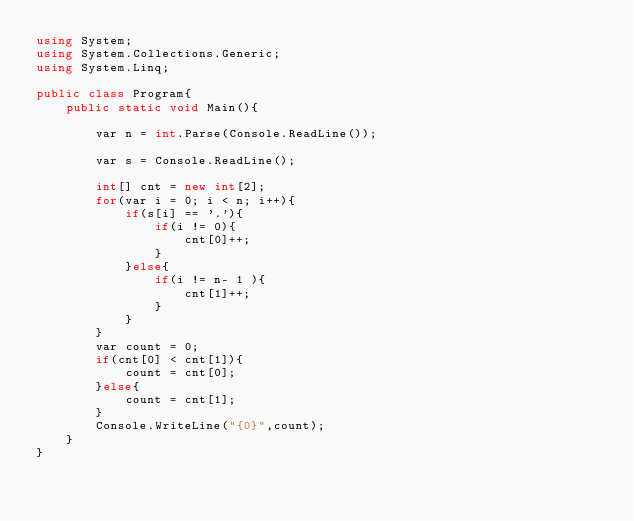<code> <loc_0><loc_0><loc_500><loc_500><_C#_>using System;
using System.Collections.Generic;
using System.Linq;

public class Program{
    public static void Main(){
        
        var n = int.Parse(Console.ReadLine());
        
        var s = Console.ReadLine();
        
        int[] cnt = new int[2];
        for(var i = 0; i < n; i++){
            if(s[i] == '.'){
                if(i != 0){
                    cnt[0]++;
                }
            }else{
                if(i != n- 1 ){
                    cnt[1]++;
                }
            }
        }
        var count = 0;
        if(cnt[0] < cnt[1]){
            count = cnt[0];
        }else{
            count = cnt[1];
        }
        Console.WriteLine("{0}",count);
    }
}
</code> 